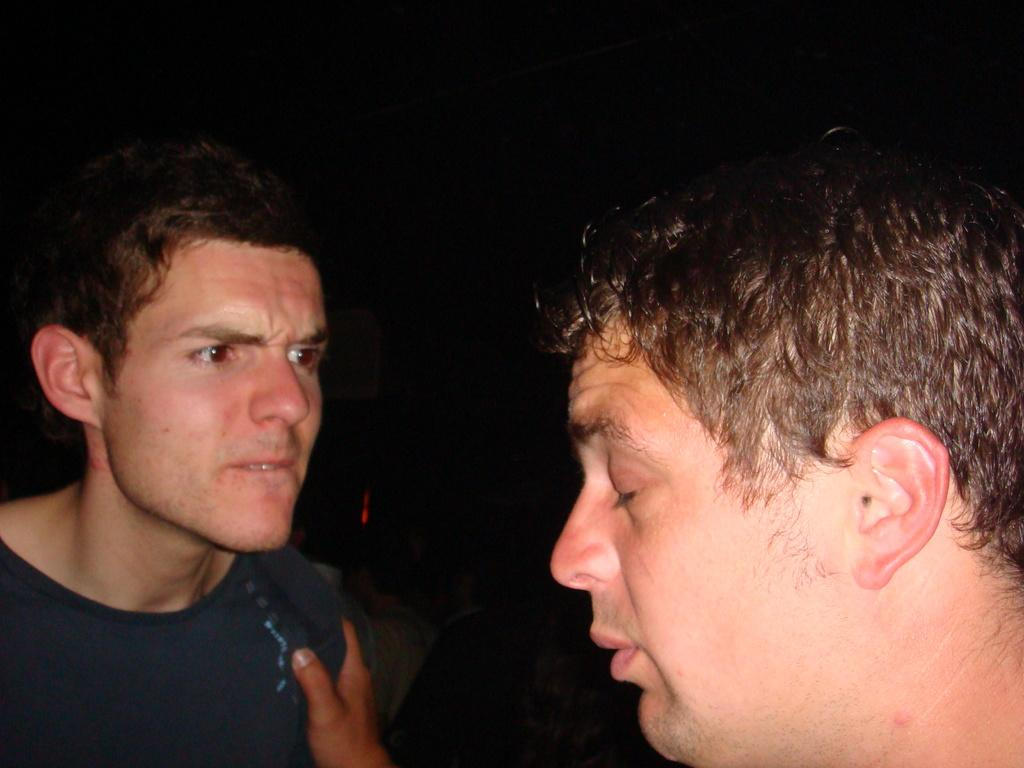How many people are in the image? There are two men in the image. What is one of the men wearing? One of the men is wearing a t-shirt. What can be observed about the background of the image? The background of the image is dark. What type of mist can be seen surrounding the men in the image? There is no mist present in the image; the background is simply dark. How many chickens are visible in the image? There are no chickens present in the image. 